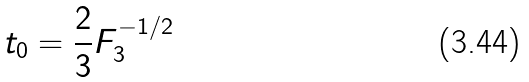<formula> <loc_0><loc_0><loc_500><loc_500>t _ { 0 } = \frac { 2 } { 3 } F _ { 3 } ^ { - 1 / 2 }</formula> 